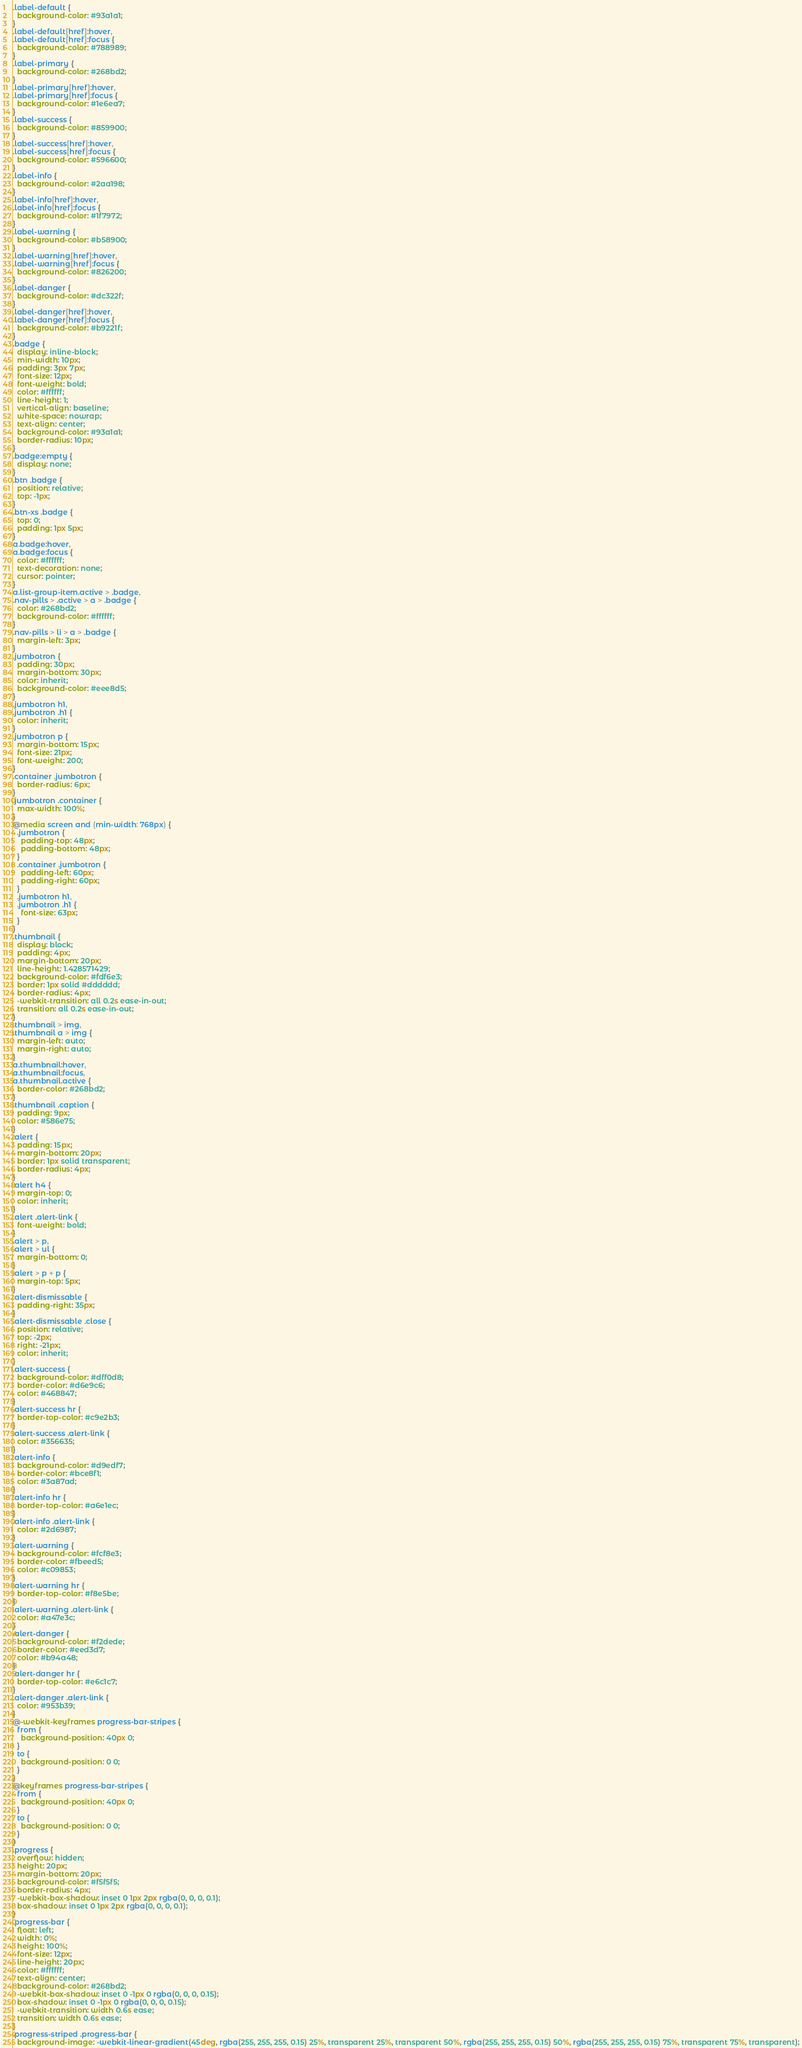<code> <loc_0><loc_0><loc_500><loc_500><_CSS_>.label-default {
  background-color: #93a1a1;
}
.label-default[href]:hover,
.label-default[href]:focus {
  background-color: #788989;
}
.label-primary {
  background-color: #268bd2;
}
.label-primary[href]:hover,
.label-primary[href]:focus {
  background-color: #1e6ea7;
}
.label-success {
  background-color: #859900;
}
.label-success[href]:hover,
.label-success[href]:focus {
  background-color: #596600;
}
.label-info {
  background-color: #2aa198;
}
.label-info[href]:hover,
.label-info[href]:focus {
  background-color: #1f7972;
}
.label-warning {
  background-color: #b58900;
}
.label-warning[href]:hover,
.label-warning[href]:focus {
  background-color: #826200;
}
.label-danger {
  background-color: #dc322f;
}
.label-danger[href]:hover,
.label-danger[href]:focus {
  background-color: #b9221f;
}
.badge {
  display: inline-block;
  min-width: 10px;
  padding: 3px 7px;
  font-size: 12px;
  font-weight: bold;
  color: #ffffff;
  line-height: 1;
  vertical-align: baseline;
  white-space: nowrap;
  text-align: center;
  background-color: #93a1a1;
  border-radius: 10px;
}
.badge:empty {
  display: none;
}
.btn .badge {
  position: relative;
  top: -1px;
}
.btn-xs .badge {
  top: 0;
  padding: 1px 5px;
}
a.badge:hover,
a.badge:focus {
  color: #ffffff;
  text-decoration: none;
  cursor: pointer;
}
a.list-group-item.active > .badge,
.nav-pills > .active > a > .badge {
  color: #268bd2;
  background-color: #ffffff;
}
.nav-pills > li > a > .badge {
  margin-left: 3px;
}
.jumbotron {
  padding: 30px;
  margin-bottom: 30px;
  color: inherit;
  background-color: #eee8d5;
}
.jumbotron h1,
.jumbotron .h1 {
  color: inherit;
}
.jumbotron p {
  margin-bottom: 15px;
  font-size: 21px;
  font-weight: 200;
}
.container .jumbotron {
  border-radius: 6px;
}
.jumbotron .container {
  max-width: 100%;
}
@media screen and (min-width: 768px) {
  .jumbotron {
    padding-top: 48px;
    padding-bottom: 48px;
  }
  .container .jumbotron {
    padding-left: 60px;
    padding-right: 60px;
  }
  .jumbotron h1,
  .jumbotron .h1 {
    font-size: 63px;
  }
}
.thumbnail {
  display: block;
  padding: 4px;
  margin-bottom: 20px;
  line-height: 1.428571429;
  background-color: #fdf6e3;
  border: 1px solid #dddddd;
  border-radius: 4px;
  -webkit-transition: all 0.2s ease-in-out;
  transition: all 0.2s ease-in-out;
}
.thumbnail > img,
.thumbnail a > img {
  margin-left: auto;
  margin-right: auto;
}
a.thumbnail:hover,
a.thumbnail:focus,
a.thumbnail.active {
  border-color: #268bd2;
}
.thumbnail .caption {
  padding: 9px;
  color: #586e75;
}
.alert {
  padding: 15px;
  margin-bottom: 20px;
  border: 1px solid transparent;
  border-radius: 4px;
}
.alert h4 {
  margin-top: 0;
  color: inherit;
}
.alert .alert-link {
  font-weight: bold;
}
.alert > p,
.alert > ul {
  margin-bottom: 0;
}
.alert > p + p {
  margin-top: 5px;
}
.alert-dismissable {
  padding-right: 35px;
}
.alert-dismissable .close {
  position: relative;
  top: -2px;
  right: -21px;
  color: inherit;
}
.alert-success {
  background-color: #dff0d8;
  border-color: #d6e9c6;
  color: #468847;
}
.alert-success hr {
  border-top-color: #c9e2b3;
}
.alert-success .alert-link {
  color: #356635;
}
.alert-info {
  background-color: #d9edf7;
  border-color: #bce8f1;
  color: #3a87ad;
}
.alert-info hr {
  border-top-color: #a6e1ec;
}
.alert-info .alert-link {
  color: #2d6987;
}
.alert-warning {
  background-color: #fcf8e3;
  border-color: #fbeed5;
  color: #c09853;
}
.alert-warning hr {
  border-top-color: #f8e5be;
}
.alert-warning .alert-link {
  color: #a47e3c;
}
.alert-danger {
  background-color: #f2dede;
  border-color: #eed3d7;
  color: #b94a48;
}
.alert-danger hr {
  border-top-color: #e6c1c7;
}
.alert-danger .alert-link {
  color: #953b39;
}
@-webkit-keyframes progress-bar-stripes {
  from {
    background-position: 40px 0;
  }
  to {
    background-position: 0 0;
  }
}
@keyframes progress-bar-stripes {
  from {
    background-position: 40px 0;
  }
  to {
    background-position: 0 0;
  }
}
.progress {
  overflow: hidden;
  height: 20px;
  margin-bottom: 20px;
  background-color: #f5f5f5;
  border-radius: 4px;
  -webkit-box-shadow: inset 0 1px 2px rgba(0, 0, 0, 0.1);
  box-shadow: inset 0 1px 2px rgba(0, 0, 0, 0.1);
}
.progress-bar {
  float: left;
  width: 0%;
  height: 100%;
  font-size: 12px;
  line-height: 20px;
  color: #ffffff;
  text-align: center;
  background-color: #268bd2;
  -webkit-box-shadow: inset 0 -1px 0 rgba(0, 0, 0, 0.15);
  box-shadow: inset 0 -1px 0 rgba(0, 0, 0, 0.15);
  -webkit-transition: width 0.6s ease;
  transition: width 0.6s ease;
}
.progress-striped .progress-bar {
  background-image: -webkit-linear-gradient(45deg, rgba(255, 255, 255, 0.15) 25%, transparent 25%, transparent 50%, rgba(255, 255, 255, 0.15) 50%, rgba(255, 255, 255, 0.15) 75%, transparent 75%, transparent);</code> 